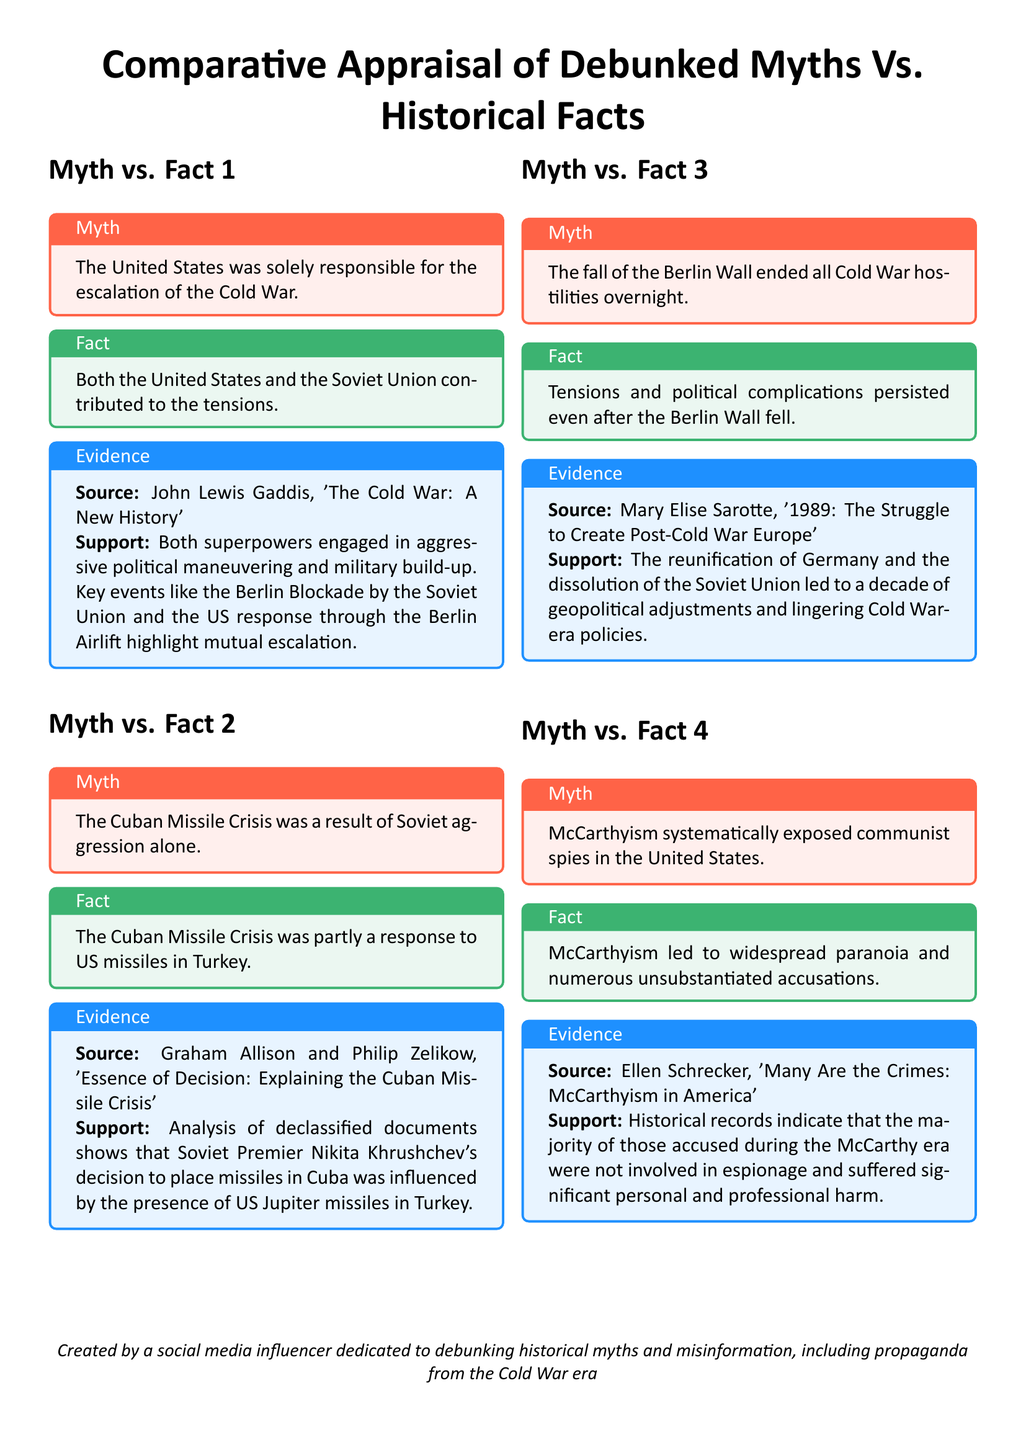What is the first myth listed? The first myth in the document states that "The United States was solely responsible for the escalation of the Cold War."
Answer: The United States was solely responsible for the escalation of the Cold War Who authored "The Cold War: A New History"? This work is referenced as the source for the information regarding the first myth, which discusses the escalation of the Cold War.
Answer: John Lewis Gaddis What is the second fact regarding the Cuban Missile Crisis? This fact states that the Cuban Missile Crisis was partly a response to US missiles in Turkey.
Answer: The Cuban Missile Crisis was partly a response to US missiles in Turkey What historical event is associated with McCarthyism in the document? The document mentions that McCarthyism led to widespread paranoia and numerous unsubstantiated accusations related to espionage.
Answer: McCarthyism How many myths are discussed in the document? The document presents a total of four myths throughout its sections.
Answer: Four What color represents myths in the document? The document specifies the color for myths, which is a shade of red.
Answer: Red What source discusses the tensions that persisted after the fall of the Berlin Wall? This source is referenced to provide evidence about the political complications after the Berlin Wall fell.
Answer: Mary Elise Sarotte, '1989: The Struggle to Create Post-Cold War Europe' What overarching theme does this document address? The document compares debunked myths to historical facts, focusing particularly on events from the Cold War era.
Answer: Comparative Appraisal of Debunked Myths Vs. Historical Facts 